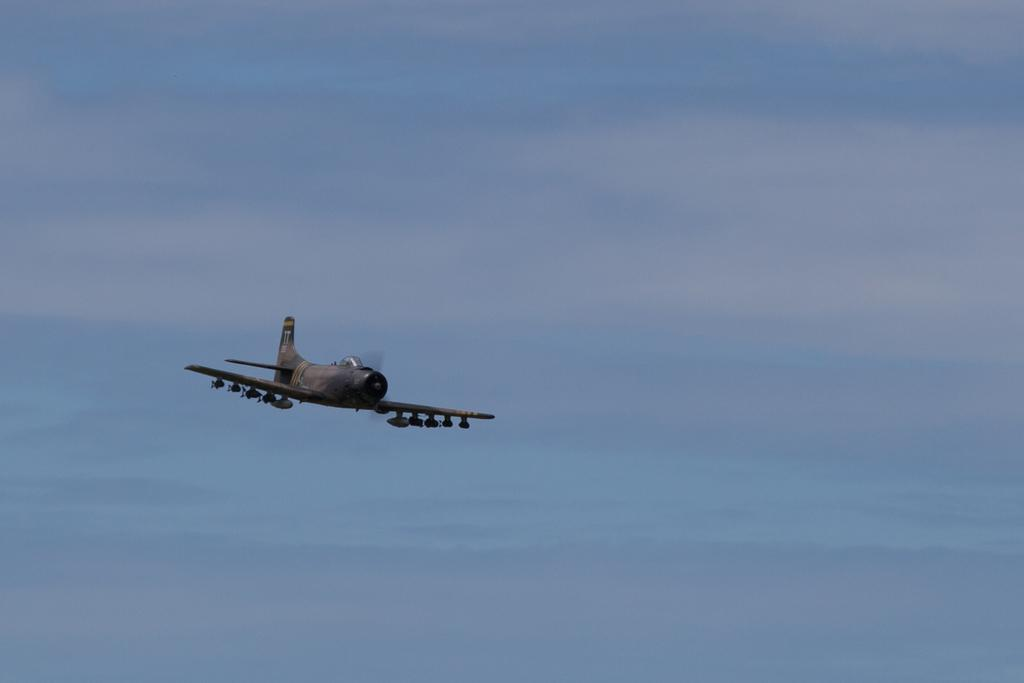What is the main subject of the image? The main subject of the image is an airplane. Where is the airplane located in the image? The airplane is in the sky. What type of disease is affecting the airplane in the image? There is no disease affecting the airplane in the image; it is simply an airplane in the sky. 